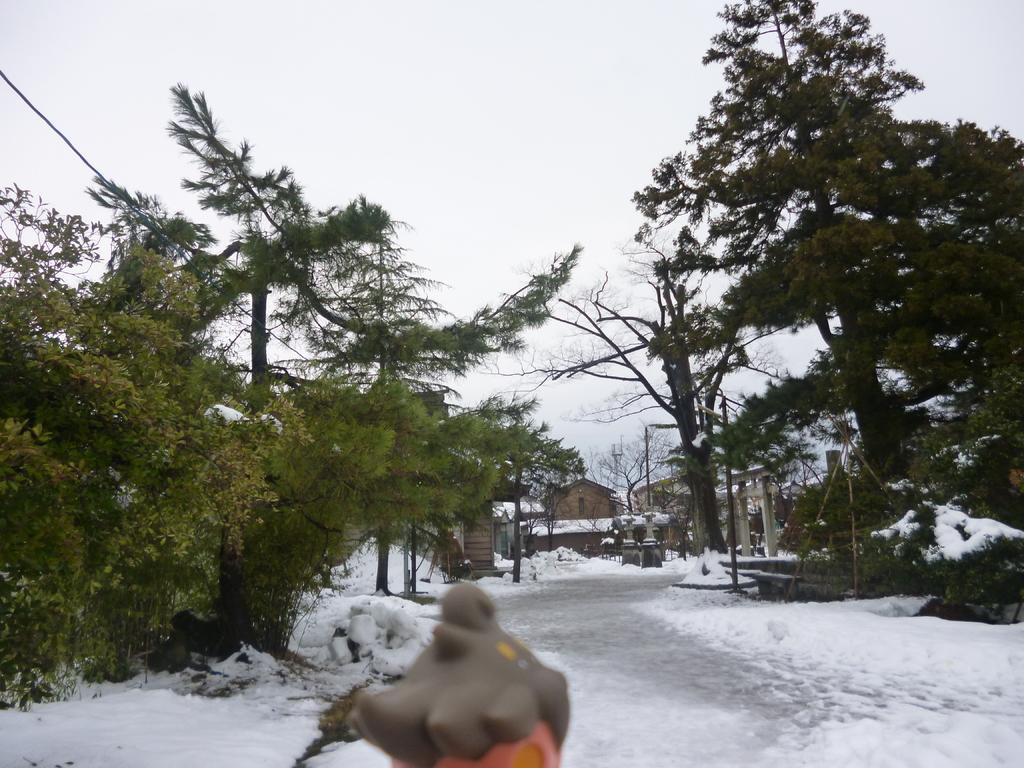How would you summarize this image in a sentence or two? In this image the land is covered with snow, in the middle there is an object, in the background there are trees, houses and the sky. 